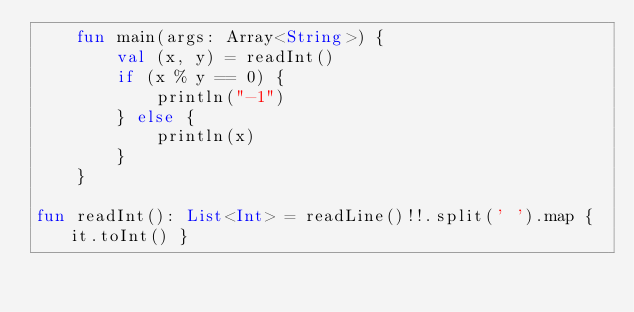Convert code to text. <code><loc_0><loc_0><loc_500><loc_500><_Kotlin_>    fun main(args: Array<String>) {
        val (x, y) = readInt()
        if (x % y == 0) {
            println("-1")
        } else {
            println(x)
        }
    }

fun readInt(): List<Int> = readLine()!!.split(' ').map { it.toInt() }</code> 